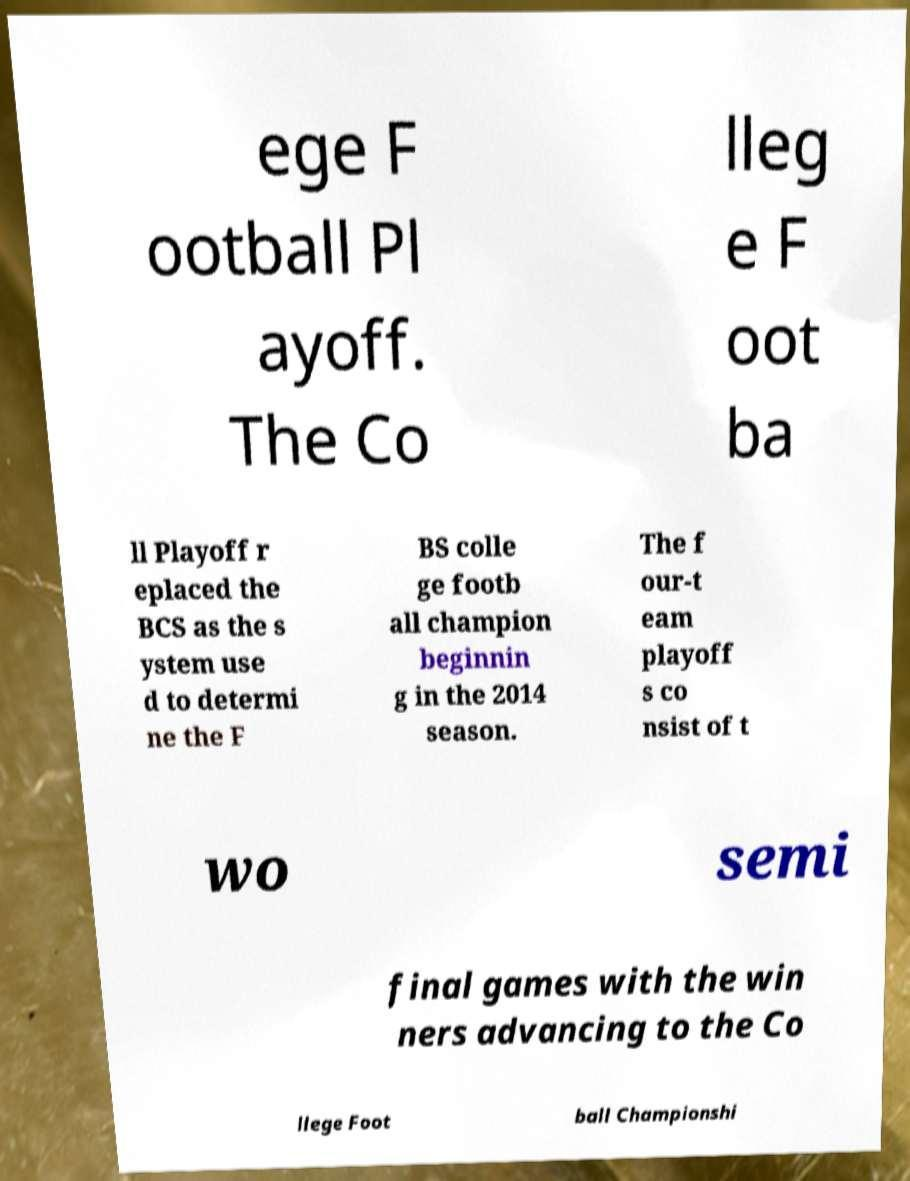Could you extract and type out the text from this image? ege F ootball Pl ayoff. The Co lleg e F oot ba ll Playoff r eplaced the BCS as the s ystem use d to determi ne the F BS colle ge footb all champion beginnin g in the 2014 season. The f our-t eam playoff s co nsist of t wo semi final games with the win ners advancing to the Co llege Foot ball Championshi 